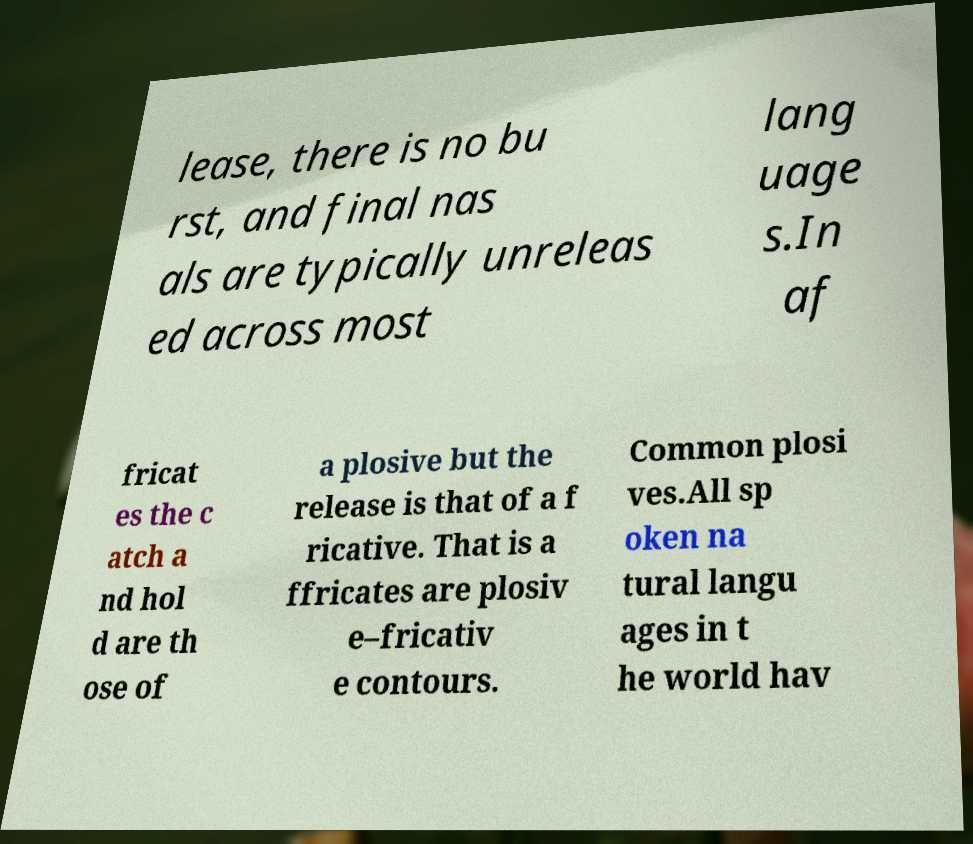Could you extract and type out the text from this image? lease, there is no bu rst, and final nas als are typically unreleas ed across most lang uage s.In af fricat es the c atch a nd hol d are th ose of a plosive but the release is that of a f ricative. That is a ffricates are plosiv e–fricativ e contours. Common plosi ves.All sp oken na tural langu ages in t he world hav 